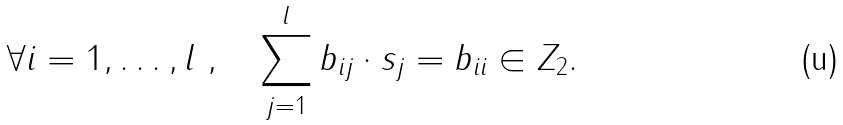Convert formula to latex. <formula><loc_0><loc_0><loc_500><loc_500>\forall i = 1 , \dots , l \ , \quad \sum _ { j = 1 } ^ { l } b _ { i j } \cdot s _ { j } = b _ { i i } \in Z _ { 2 } .</formula> 